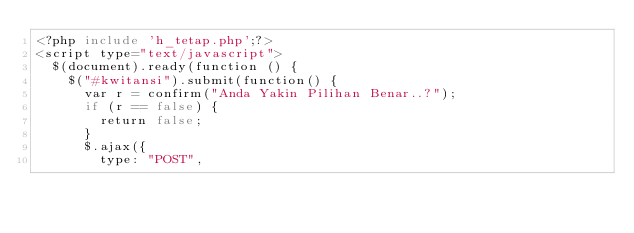Convert code to text. <code><loc_0><loc_0><loc_500><loc_500><_PHP_><?php include 'h_tetap.php';?>
<script type="text/javascript">
	$(document).ready(function () {
		$("#kwitansi").submit(function() {
			var r = confirm("Anda Yakin Pilihan Benar..?");
			if (r == false) {
				return false;
			}
			$.ajax({
				type: "POST",</code> 